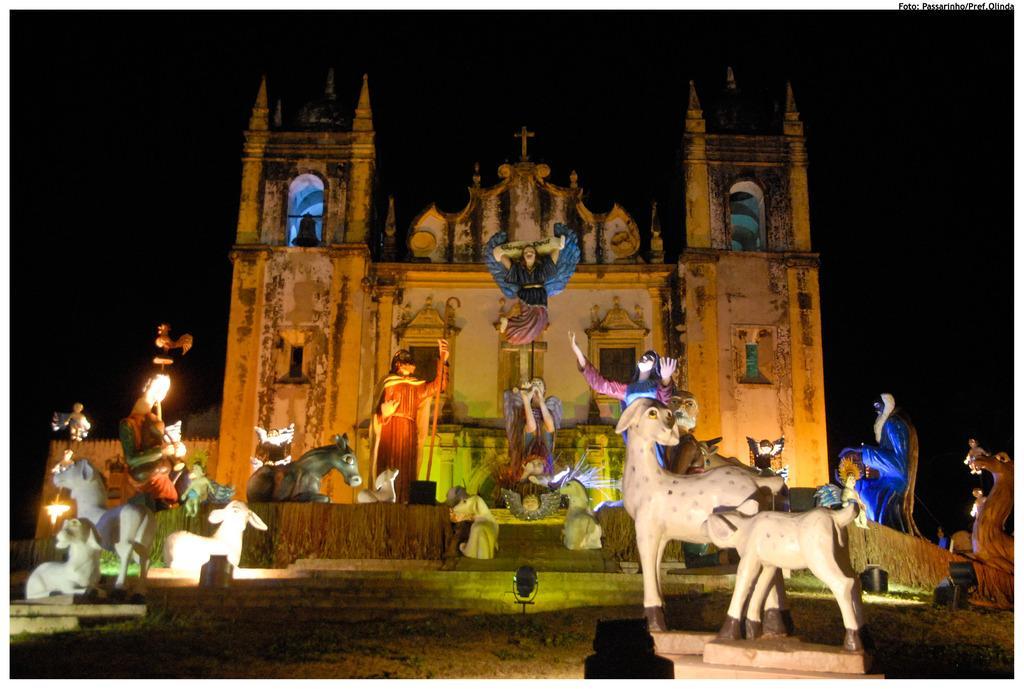Could you give a brief overview of what you see in this image? In this image, we can see there are statues of the persons and animals arranged on the platform. In the background, there is a building. And the background is dark in color. 